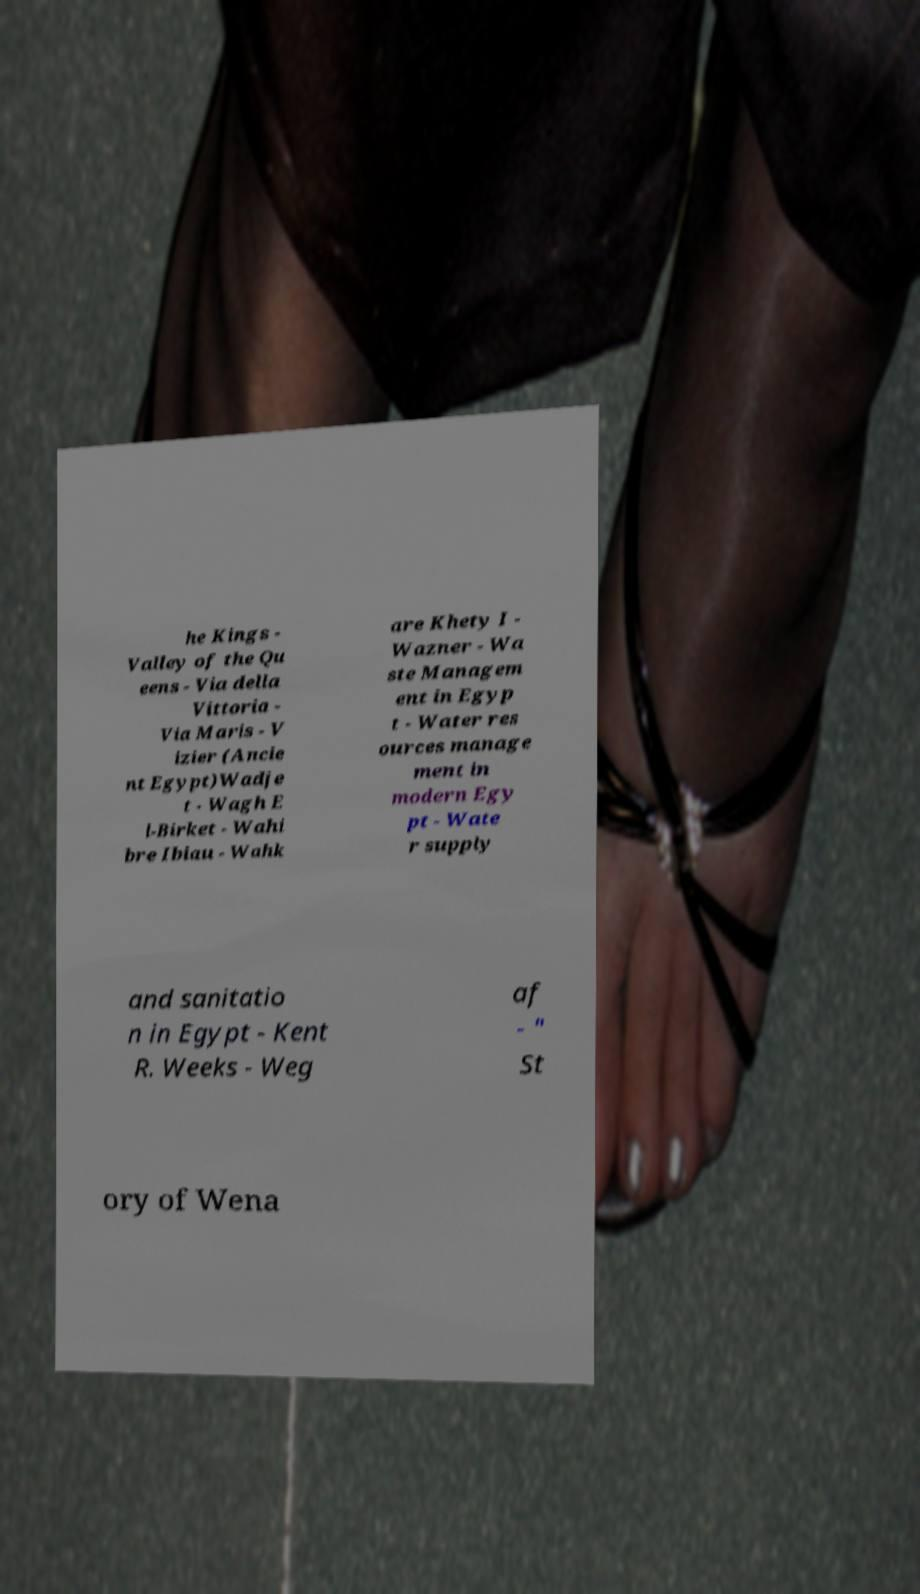Please identify and transcribe the text found in this image. he Kings - Valley of the Qu eens - Via della Vittoria - Via Maris - V izier (Ancie nt Egypt)Wadje t - Wagh E l-Birket - Wahi bre Ibiau - Wahk are Khety I - Wazner - Wa ste Managem ent in Egyp t - Water res ources manage ment in modern Egy pt - Wate r supply and sanitatio n in Egypt - Kent R. Weeks - Weg af - " St ory of Wena 